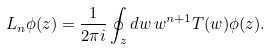<formula> <loc_0><loc_0><loc_500><loc_500>L _ { n } \phi ( z ) = \frac { 1 } { 2 \pi i } \oint _ { z } d w \, w ^ { n + 1 } T ( w ) \phi ( z ) .</formula> 